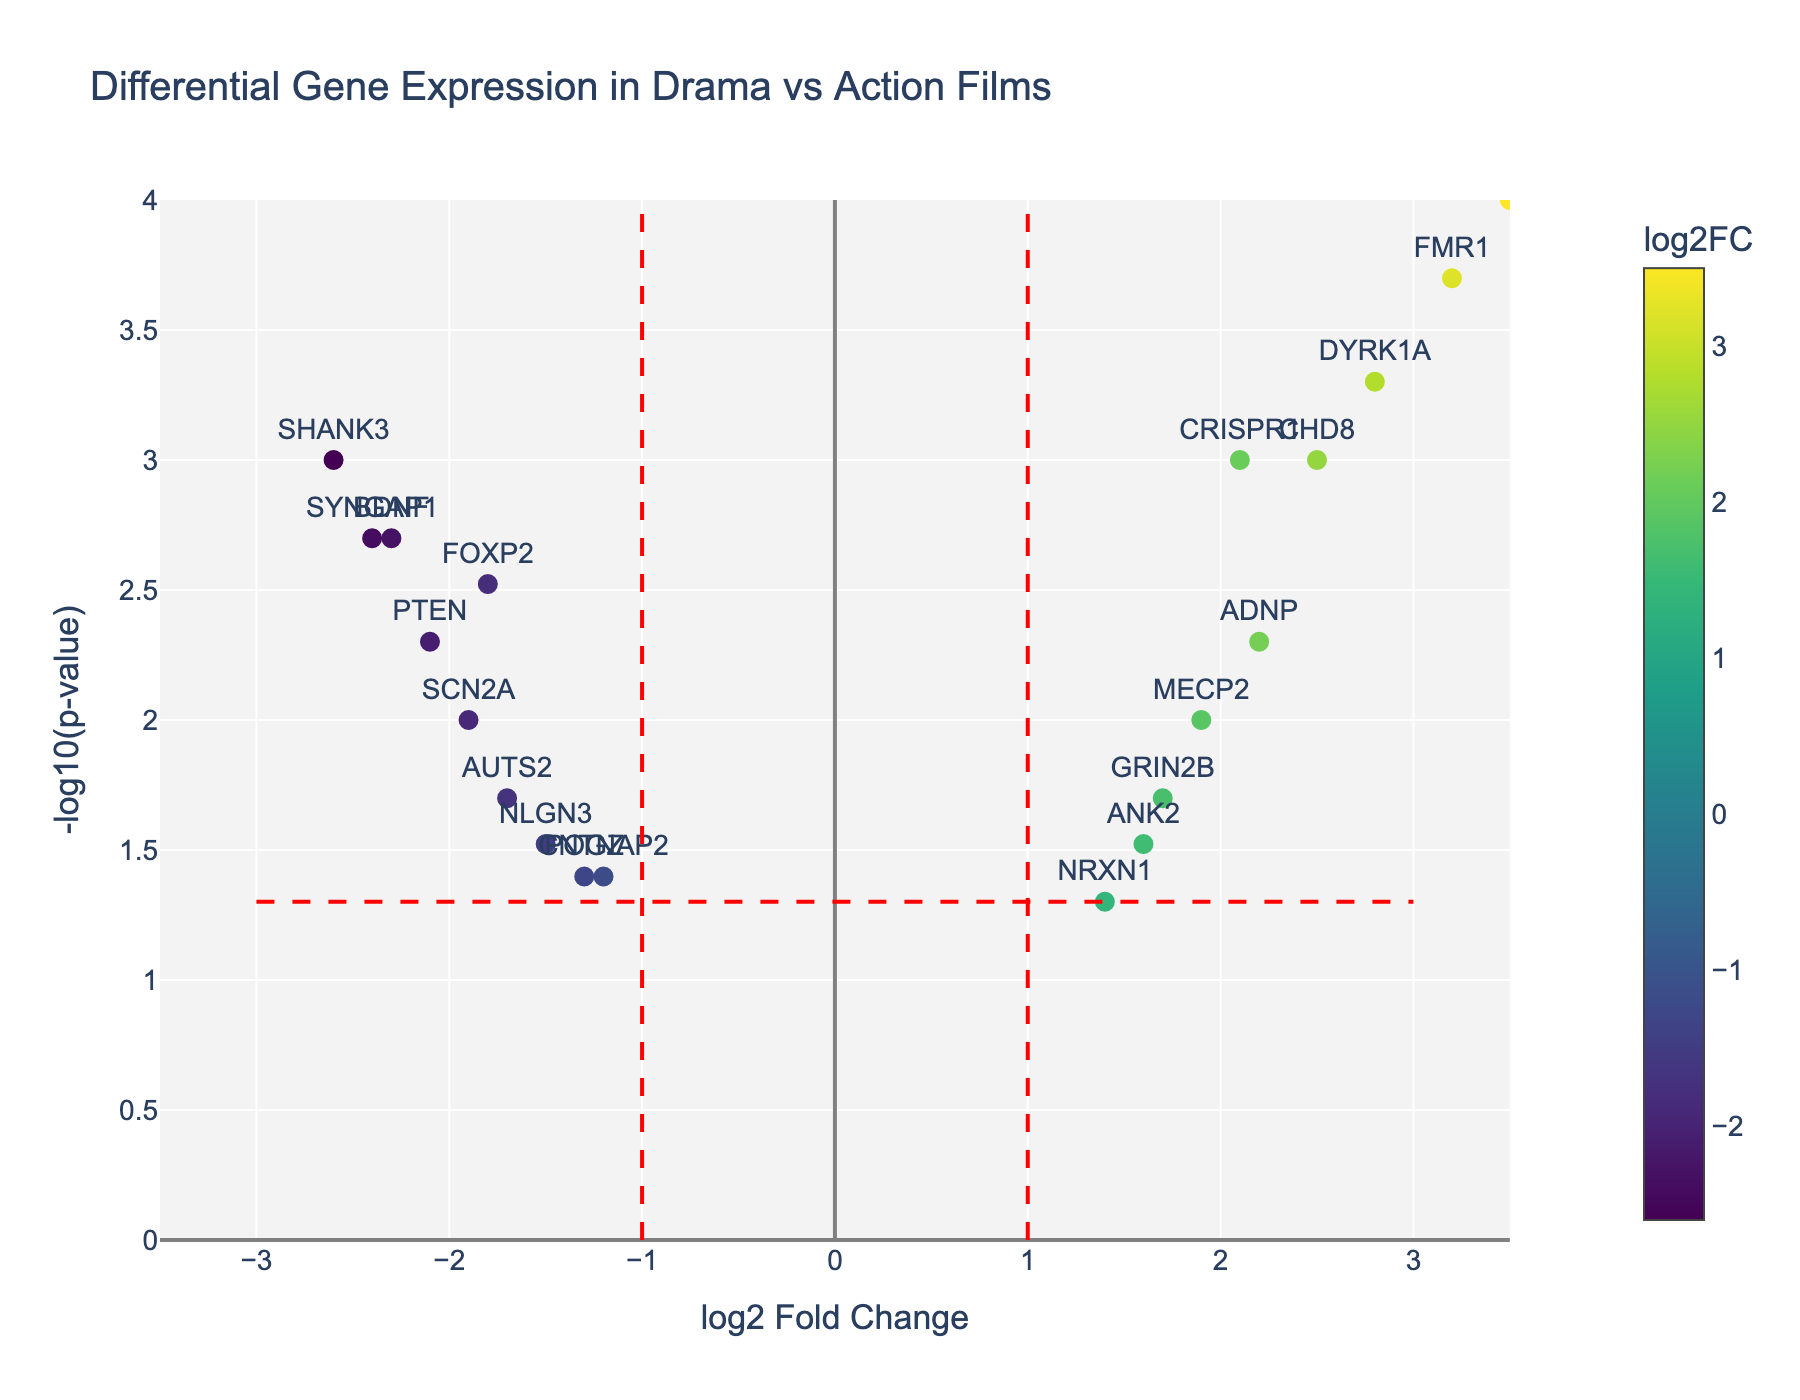How many genes are represented in the plot? Count the number of unique gene labels displayed in the plot. Each gene represents one data point.
Answer: 20 What is the gene with the highest -log10(p-value)? Identify the point with the highest y-axis value, which corresponds to the highest -log10(p-value). Check the gene label for that point.
Answer: NEUROD2 Which gene has the largest positive log2 Fold Change (log2FC)? Look for the data point farthest to the right on the x-axis, which indicates the largest positive log2FC. Check the gene label for that point.
Answer: NEUROD2 Which gene has the largest negative log2 Fold Change (log2FC)? Look for the data point farthest to the left on the x-axis, which indicates the largest negative log2FC. Check the gene label for that point.
Answer: SHANK3 How many genes have a p-value less than 0.01? Identify points above the horizontal line that represents the -log10(0.01) threshold. Count how many points fall above this line.
Answer: 9 Which genes are significantly differentially expressed (p-value < 0.05) and have a log2 Fold Change (log2FC) greater than 1 or less than -1? Identify points that are both above the -log10(0.05) line and outside the vertical lines at log2FC of 1 and -1. Count those points and check their gene labels.
Answer: CRISPR1, FOXP2, NEUROD2, BDNF, DYRK1A, SHANK3, FMR1, PTEN, CHD8, SYNGAP1, ADNP Which gene with a log2 Fold Change (log2FC) greater than 2 has the lowest p-value? Among the points with a log2FC greater than 2, find the one with the highest -log10(p-value) to identify the lowest p-value.
Answer: NEUROD2 